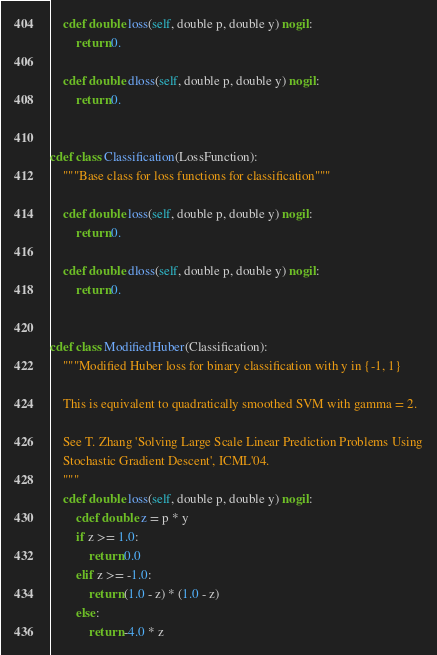Convert code to text. <code><loc_0><loc_0><loc_500><loc_500><_Cython_>    cdef double loss(self, double p, double y) nogil:
        return 0.

    cdef double dloss(self, double p, double y) nogil:
        return 0.


cdef class Classification(LossFunction):
    """Base class for loss functions for classification"""

    cdef double loss(self, double p, double y) nogil:
        return 0.

    cdef double dloss(self, double p, double y) nogil:
        return 0.


cdef class ModifiedHuber(Classification):
    """Modified Huber loss for binary classification with y in {-1, 1}

    This is equivalent to quadratically smoothed SVM with gamma = 2.

    See T. Zhang 'Solving Large Scale Linear Prediction Problems Using
    Stochastic Gradient Descent', ICML'04.
    """
    cdef double loss(self, double p, double y) nogil:
        cdef double z = p * y
        if z >= 1.0:
            return 0.0
        elif z >= -1.0:
            return (1.0 - z) * (1.0 - z)
        else:
            return -4.0 * z
</code> 